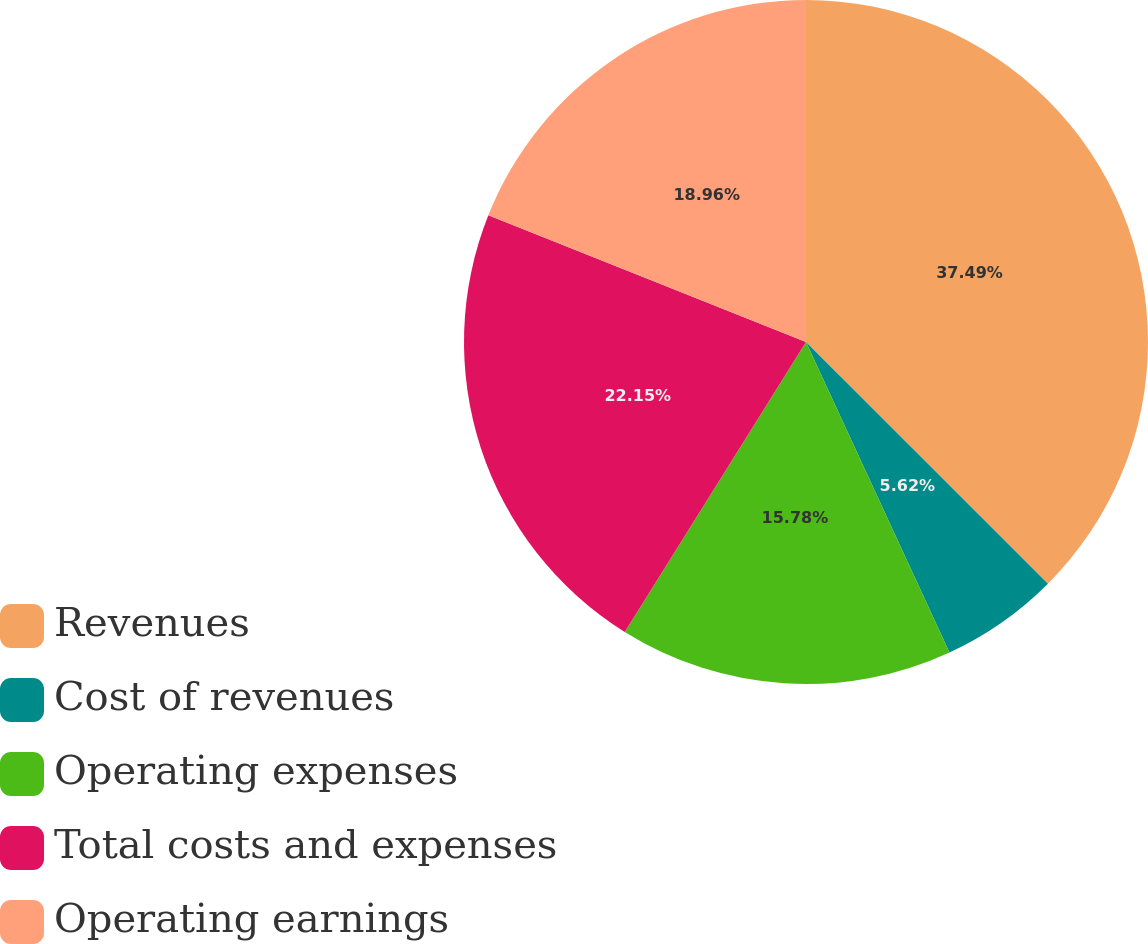Convert chart to OTSL. <chart><loc_0><loc_0><loc_500><loc_500><pie_chart><fcel>Revenues<fcel>Cost of revenues<fcel>Operating expenses<fcel>Total costs and expenses<fcel>Operating earnings<nl><fcel>37.49%<fcel>5.62%<fcel>15.78%<fcel>22.15%<fcel>18.96%<nl></chart> 